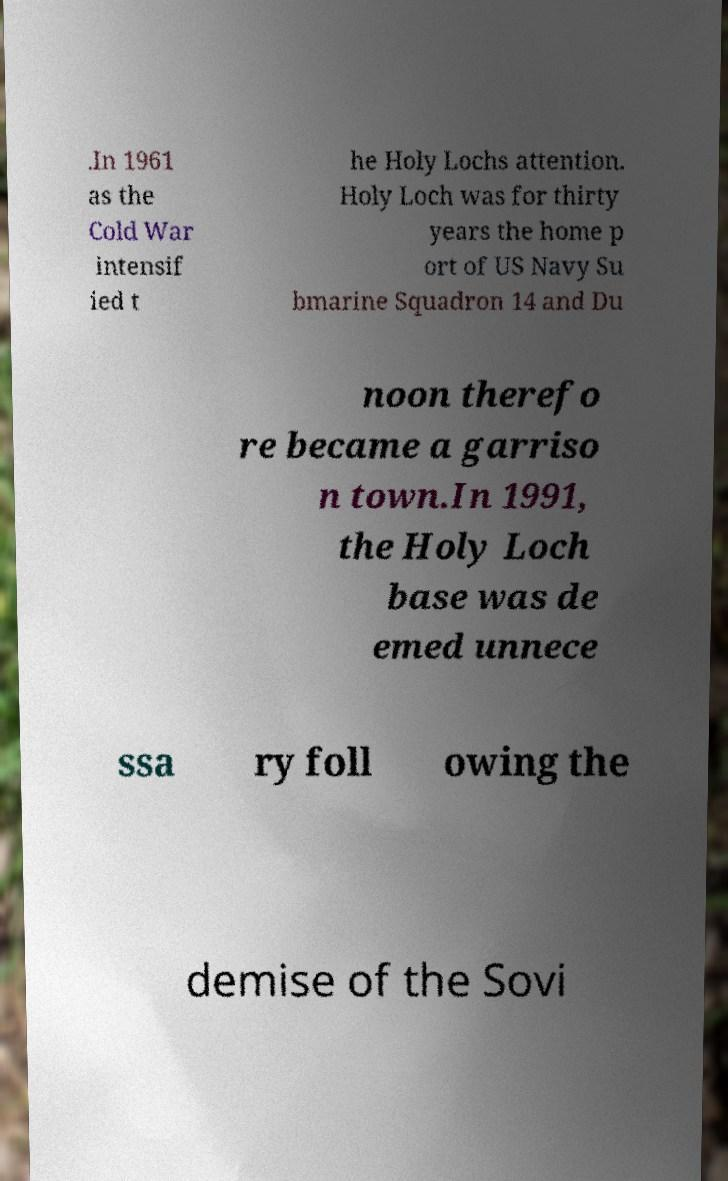There's text embedded in this image that I need extracted. Can you transcribe it verbatim? .In 1961 as the Cold War intensif ied t he Holy Lochs attention. Holy Loch was for thirty years the home p ort of US Navy Su bmarine Squadron 14 and Du noon therefo re became a garriso n town.In 1991, the Holy Loch base was de emed unnece ssa ry foll owing the demise of the Sovi 